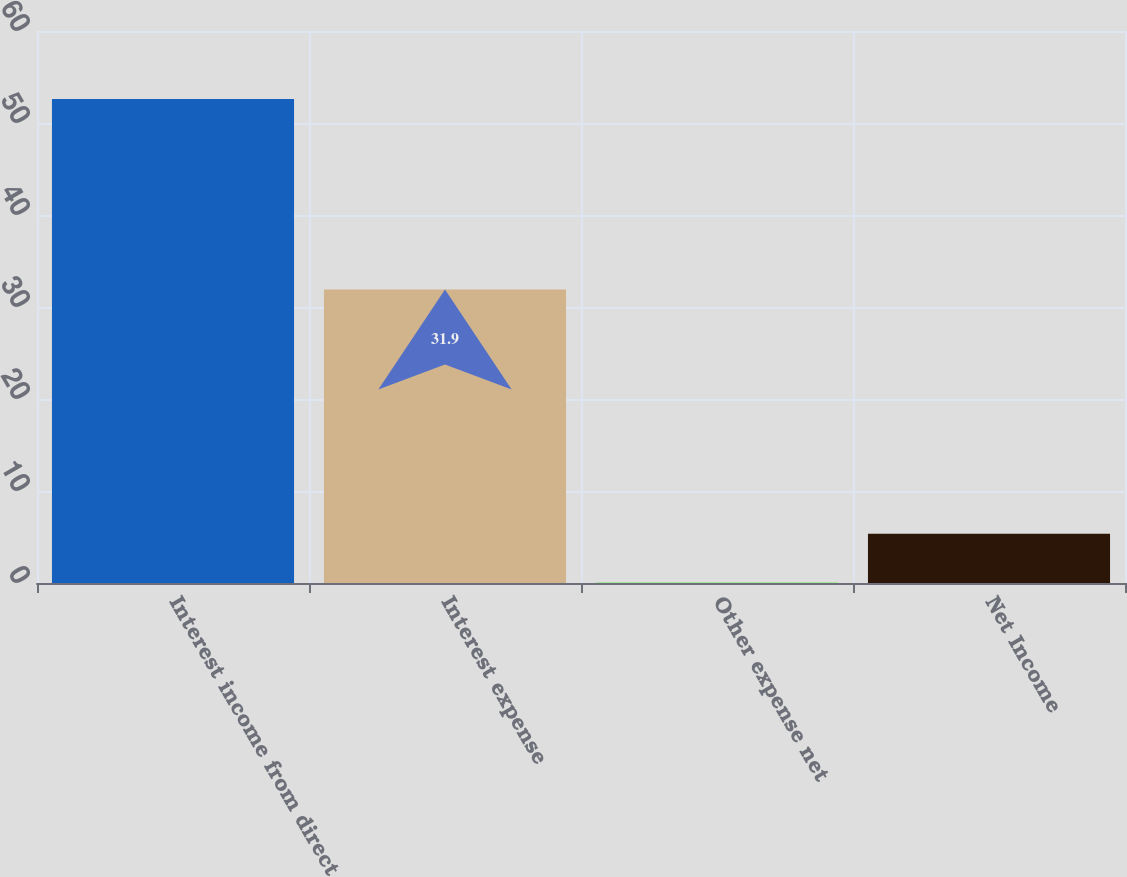<chart> <loc_0><loc_0><loc_500><loc_500><bar_chart><fcel>Interest income from direct<fcel>Interest expense<fcel>Other expense net<fcel>Net Income<nl><fcel>52.6<fcel>31.9<fcel>0.1<fcel>5.35<nl></chart> 